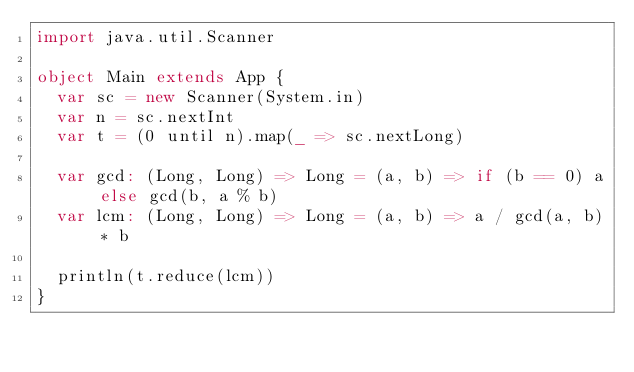Convert code to text. <code><loc_0><loc_0><loc_500><loc_500><_Scala_>import java.util.Scanner

object Main extends App {
  var sc = new Scanner(System.in)
  var n = sc.nextInt
  var t = (0 until n).map(_ => sc.nextLong)

  var gcd: (Long, Long) => Long = (a, b) => if (b == 0) a else gcd(b, a % b)
  var lcm: (Long, Long) => Long = (a, b) => a / gcd(a, b) * b

  println(t.reduce(lcm))
}</code> 